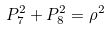Convert formula to latex. <formula><loc_0><loc_0><loc_500><loc_500>P _ { 7 } ^ { 2 } + P _ { 8 } ^ { 2 } = \rho ^ { 2 }</formula> 